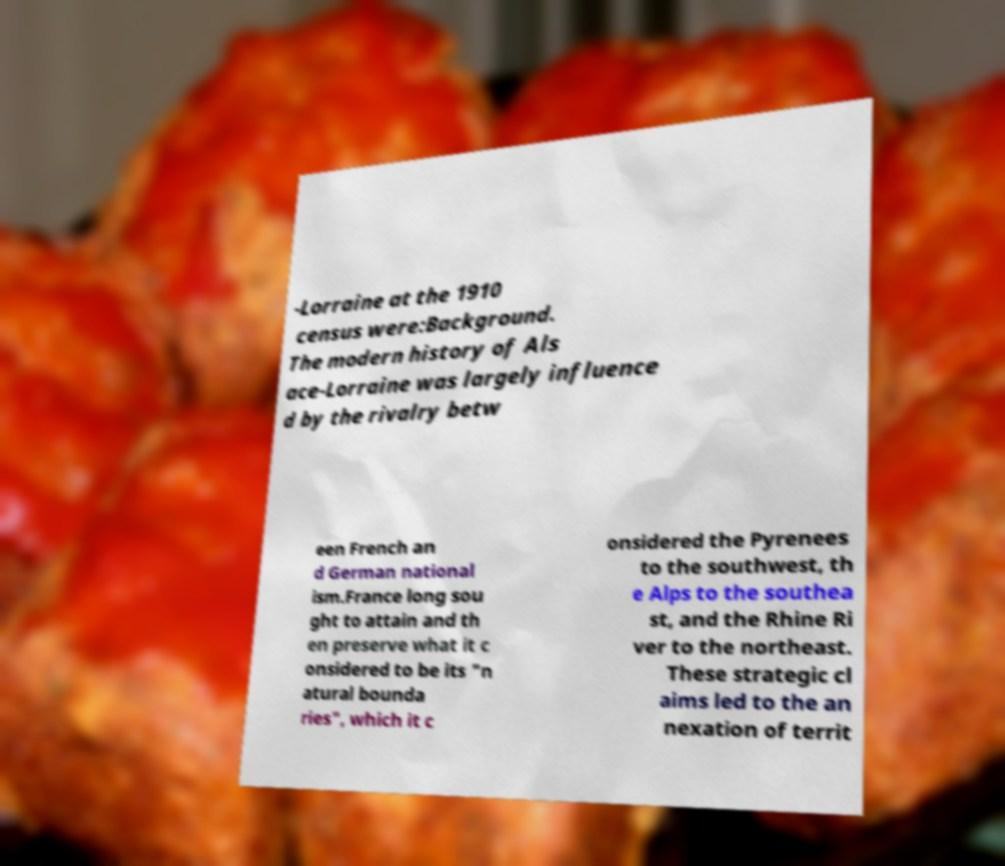I need the written content from this picture converted into text. Can you do that? -Lorraine at the 1910 census were:Background. The modern history of Als ace-Lorraine was largely influence d by the rivalry betw een French an d German national ism.France long sou ght to attain and th en preserve what it c onsidered to be its "n atural bounda ries", which it c onsidered the Pyrenees to the southwest, th e Alps to the southea st, and the Rhine Ri ver to the northeast. These strategic cl aims led to the an nexation of territ 